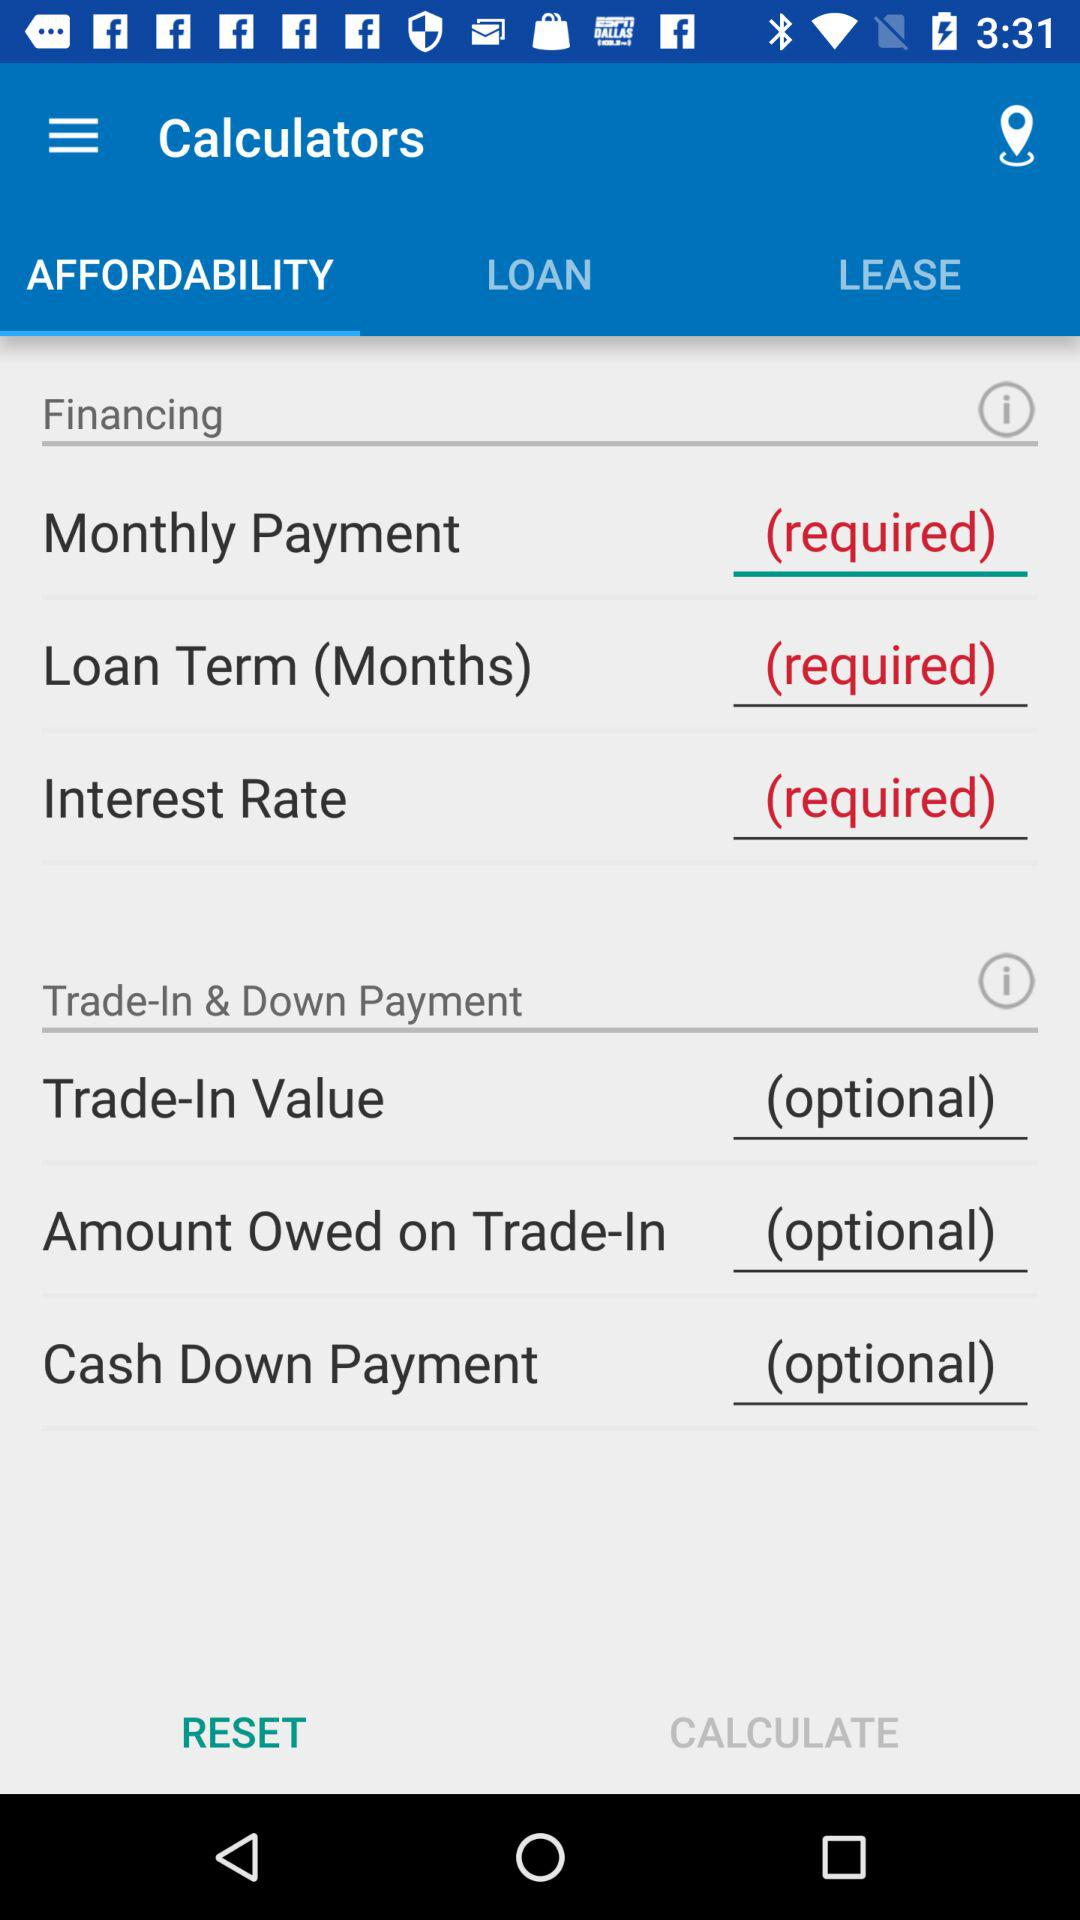What is the name of the application? The name of the application is "Calculators". 